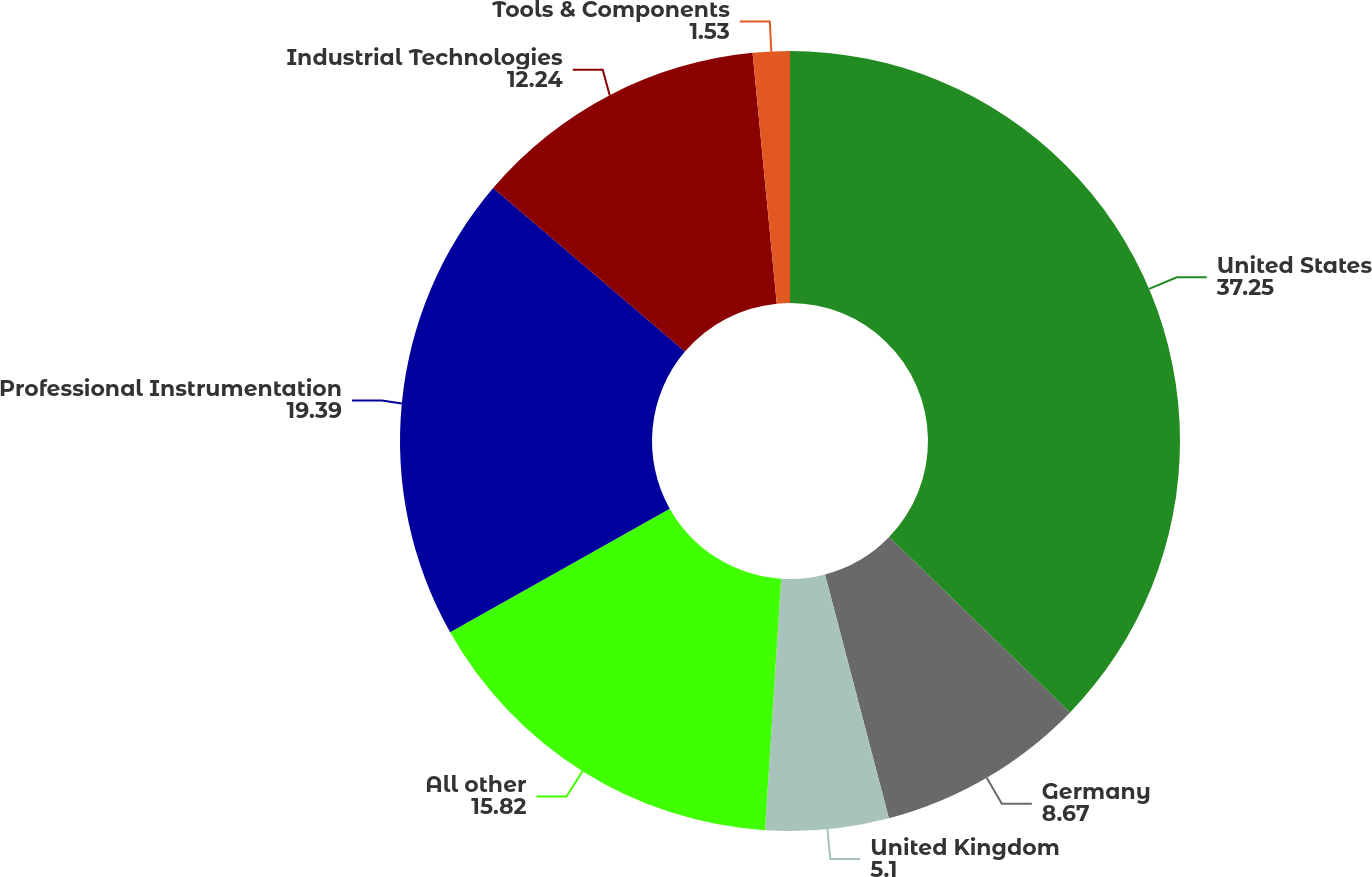Convert chart. <chart><loc_0><loc_0><loc_500><loc_500><pie_chart><fcel>United States<fcel>Germany<fcel>United Kingdom<fcel>All other<fcel>Professional Instrumentation<fcel>Industrial Technologies<fcel>Tools & Components<nl><fcel>37.25%<fcel>8.67%<fcel>5.1%<fcel>15.82%<fcel>19.39%<fcel>12.24%<fcel>1.53%<nl></chart> 